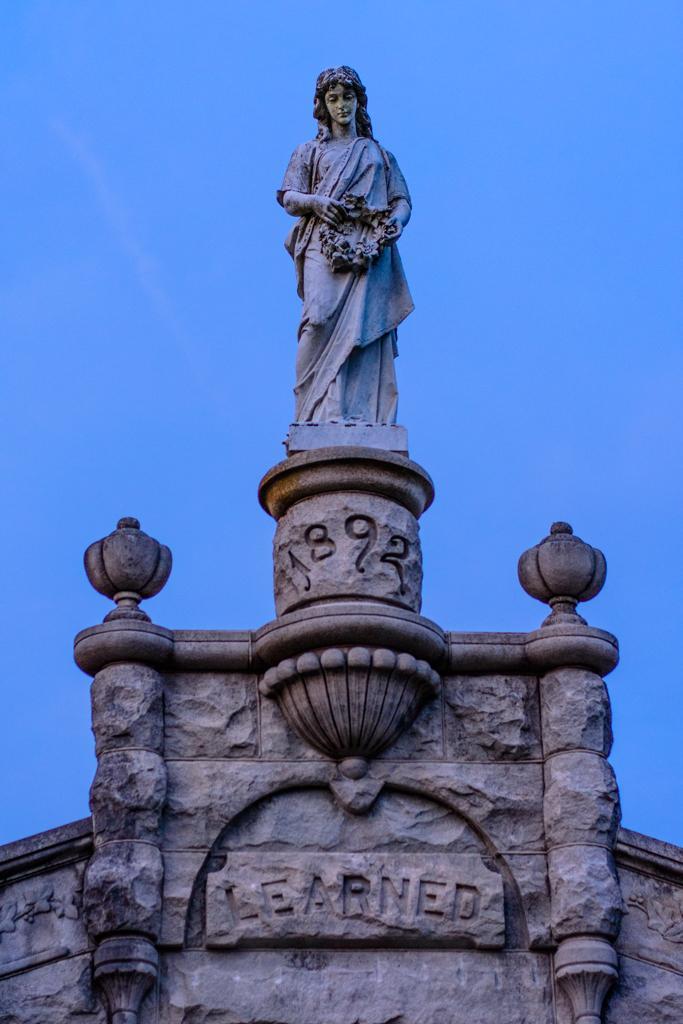Could you give a brief overview of what you see in this image? In this image I can see a statue standing on the building and the building is in white color. Background the sky is in blue color. 